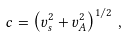<formula> <loc_0><loc_0><loc_500><loc_500>c = \left ( v _ { s } ^ { 2 } + v _ { A } ^ { 2 } \right ) ^ { 1 / 2 } \, ,</formula> 